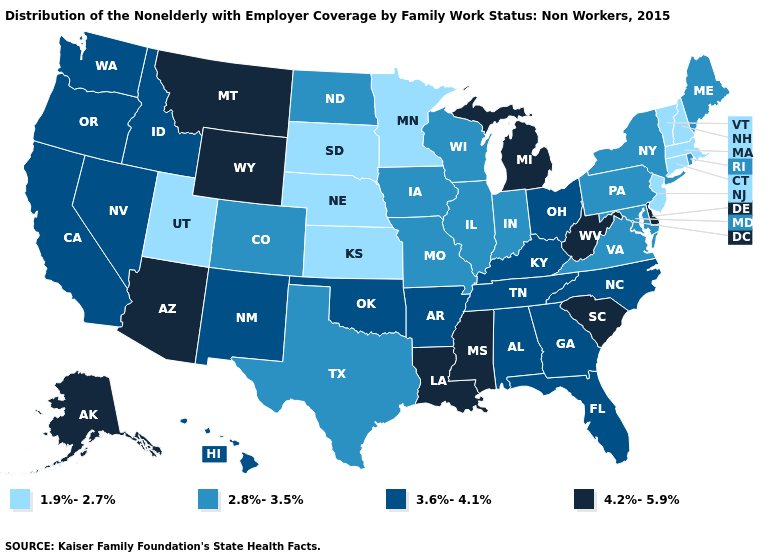Is the legend a continuous bar?
Write a very short answer. No. Name the states that have a value in the range 4.2%-5.9%?
Write a very short answer. Alaska, Arizona, Delaware, Louisiana, Michigan, Mississippi, Montana, South Carolina, West Virginia, Wyoming. What is the value of Alabama?
Answer briefly. 3.6%-4.1%. What is the value of Utah?
Answer briefly. 1.9%-2.7%. What is the value of Wisconsin?
Give a very brief answer. 2.8%-3.5%. Does Kentucky have the same value as North Carolina?
Keep it brief. Yes. Does Oregon have the highest value in the USA?
Give a very brief answer. No. What is the highest value in the USA?
Concise answer only. 4.2%-5.9%. What is the highest value in the USA?
Quick response, please. 4.2%-5.9%. Name the states that have a value in the range 2.8%-3.5%?
Answer briefly. Colorado, Illinois, Indiana, Iowa, Maine, Maryland, Missouri, New York, North Dakota, Pennsylvania, Rhode Island, Texas, Virginia, Wisconsin. Name the states that have a value in the range 1.9%-2.7%?
Be succinct. Connecticut, Kansas, Massachusetts, Minnesota, Nebraska, New Hampshire, New Jersey, South Dakota, Utah, Vermont. Name the states that have a value in the range 1.9%-2.7%?
Quick response, please. Connecticut, Kansas, Massachusetts, Minnesota, Nebraska, New Hampshire, New Jersey, South Dakota, Utah, Vermont. Which states have the lowest value in the USA?
Short answer required. Connecticut, Kansas, Massachusetts, Minnesota, Nebraska, New Hampshire, New Jersey, South Dakota, Utah, Vermont. Among the states that border Tennessee , does Missouri have the lowest value?
Quick response, please. Yes. Name the states that have a value in the range 2.8%-3.5%?
Write a very short answer. Colorado, Illinois, Indiana, Iowa, Maine, Maryland, Missouri, New York, North Dakota, Pennsylvania, Rhode Island, Texas, Virginia, Wisconsin. 